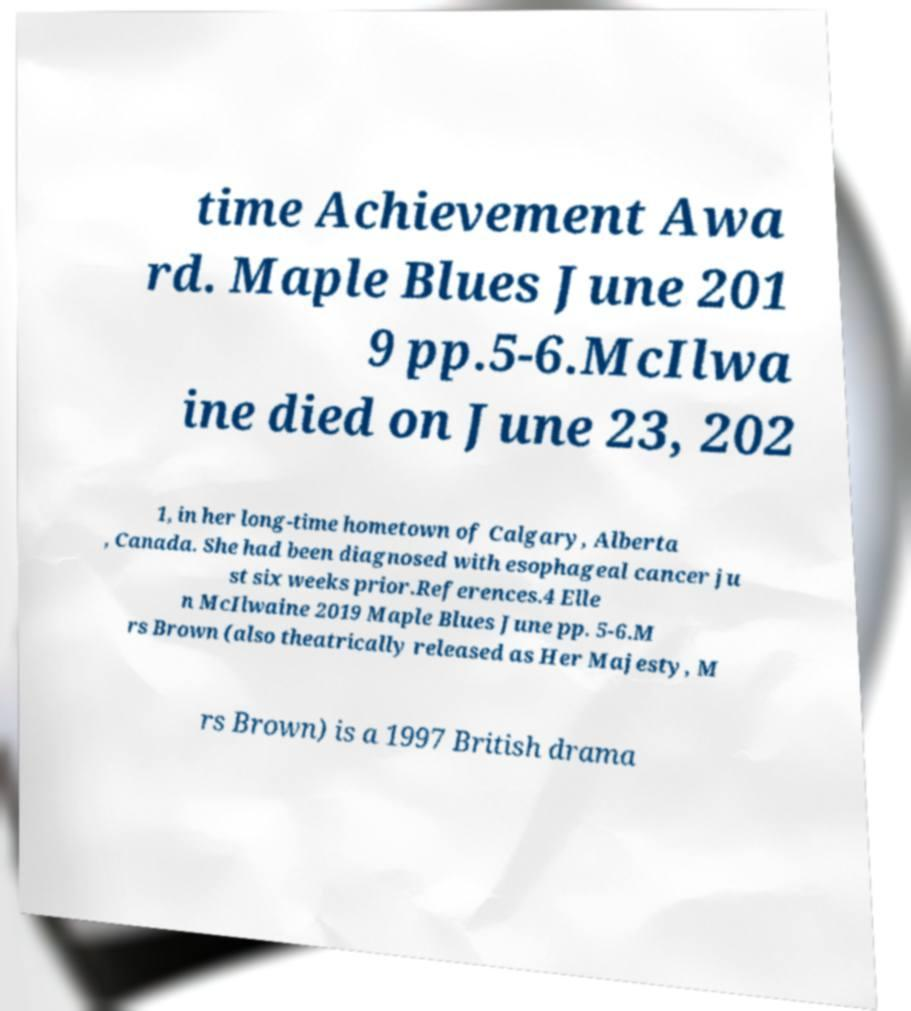Please identify and transcribe the text found in this image. time Achievement Awa rd. Maple Blues June 201 9 pp.5-6.McIlwa ine died on June 23, 202 1, in her long-time hometown of Calgary, Alberta , Canada. She had been diagnosed with esophageal cancer ju st six weeks prior.References.4 Elle n McIlwaine 2019 Maple Blues June pp. 5-6.M rs Brown (also theatrically released as Her Majesty, M rs Brown) is a 1997 British drama 